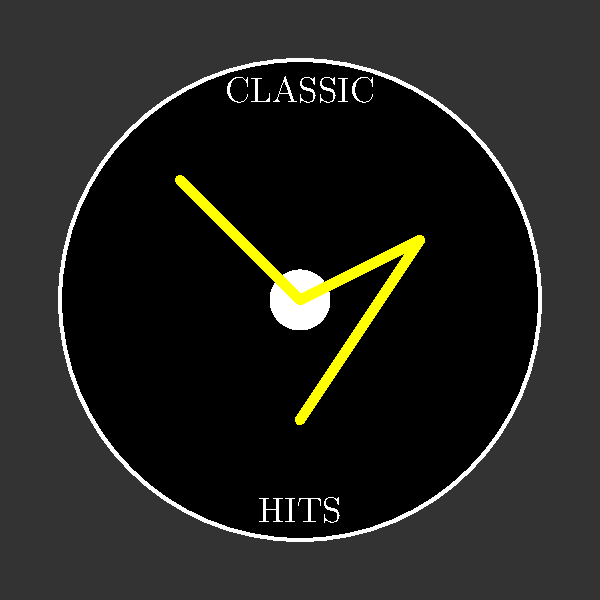Which iconic rock band's album cover does this simplified artwork most closely resemble, known for their classic hit "Thunderstruck"? 1. The artwork shows a stylized album cover with a dark background, reminiscent of many classic rock albums.
2. The central element is a black circle, representing a vinyl record, which is fitting for a classic hits listener.
3. A yellow lightning bolt is prominently featured across the "record," which is a key visual element.
4. The words "CLASSIC" and "HITS" are included, emphasizing the genre and era of the music.
5. The lightning bolt is a signature symbol associated with AC/DC, particularly on their album "High Voltage."
6. AC/DC is known for their classic hit "Thunderstruck," which aligns with the lightning imagery.
7. While this is not an exact replica of any specific AC/DC album cover, it combines elements that strongly evoke their visual style and branding.
Answer: AC/DC 